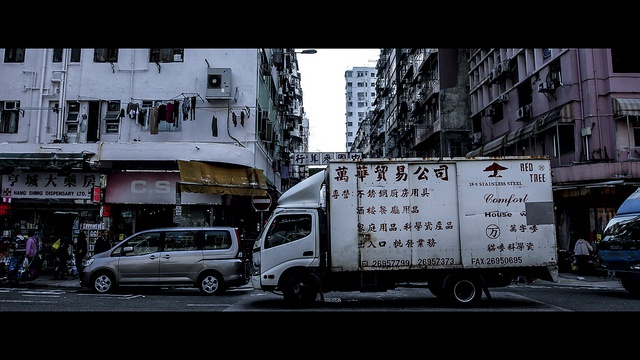Describe the objects in this image and their specific colors. I can see truck in black, darkgray, and gray tones, car in black and gray tones, people in black, gray, and darkblue tones, people in black, purple, and navy tones, and people in black, gray, and navy tones in this image. 